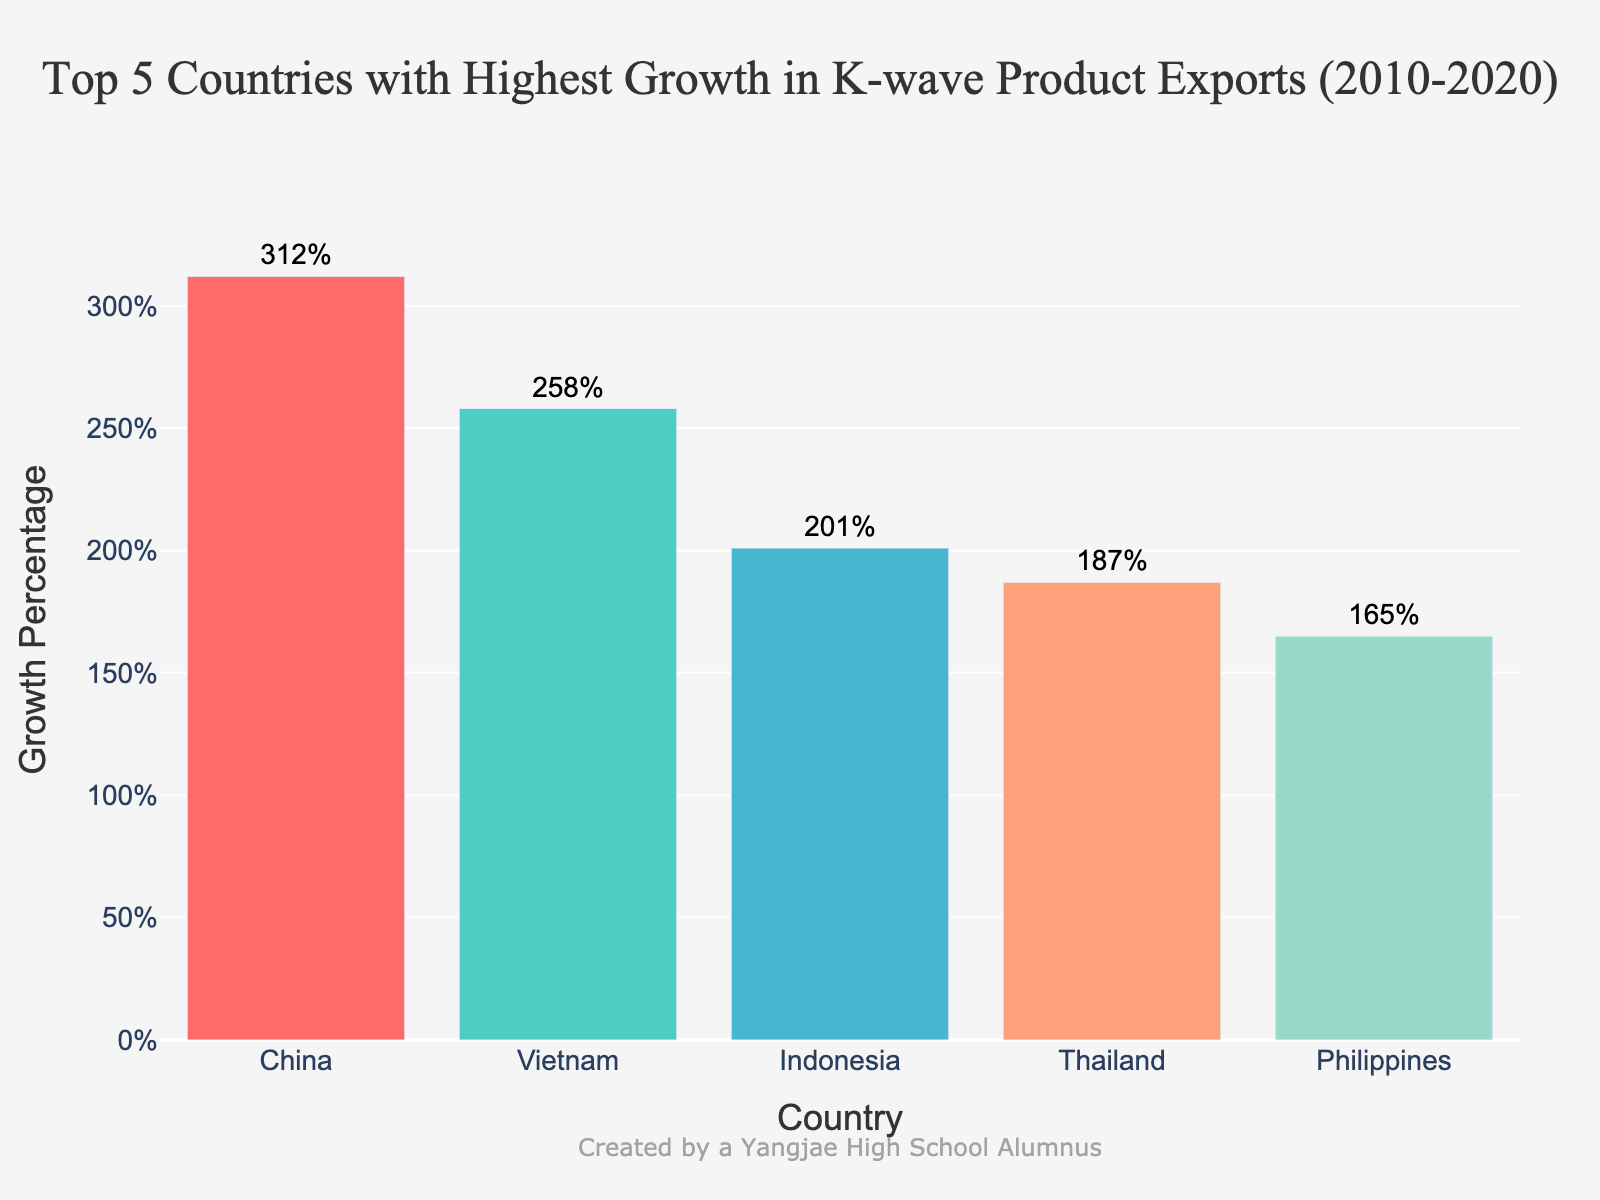what is the highest growth percentage? The bar chart shows the growth percentages of the top 5 countries for K-wave product exports. By observing the chart, the highest bar represents China with a label indicating 312%.
Answer: 312% which country has the third highest growth percentage? Examining the heights and labels of the bars on the chart, the third tallest bar corresponds to Indonesia with a growth percentage of 201%.
Answer: Indonesia What is the sum of growth percentages for Indonesia and Thailand? The growth percentage for Indonesia is 201% and for Thailand is 187%. Adding these two values together gives 201% + 187% = 388%.
Answer: 388% compare the growth percentages of China and Vietnam. Which one is higher and by how much? The growth percentage for China is 312% and for Vietnam is 258%. Subtracting Vietnam's percentage from China's gives 312% - 258% = 54%. Thus, China's growth percentage is higher by 54%.
Answer: China, by 54% what color represents the bar for the Philippines? By examining the colors of the bars in the chart, the bar for the Philippines is represented by a light green color.
Answer: light green what is the average growth percentage of the top 5 countries? The growth percentages for the five countries are 312%, 258%, 201%, 187%, and 165%. Summing these percentages gives 312 + 258 + 201 + 187 + 165 = 1123. Dividing this sum by 5 gives the average growth percentage: 1123 / 5 = 224.6%.
Answer: 224.6% is there a country with a growth percentage below 170%? If so, which one? By examining the growth percentages, we can see that the Philippines has a growth percentage of 165%, which is below 170%.
Answer: Philippines what is the median growth percentage among the top 5 countries? The growth percentages when sorted are [165, 187, 201, 258, 312]. The median value is the middle one, which is 201%.
Answer: 201% which country has the shortest bar in the chart, and what is its growth percentage? The shortest bar represents the Philippines, and its label shows a growth percentage of 165%.
Answer: Philippines, 165% 